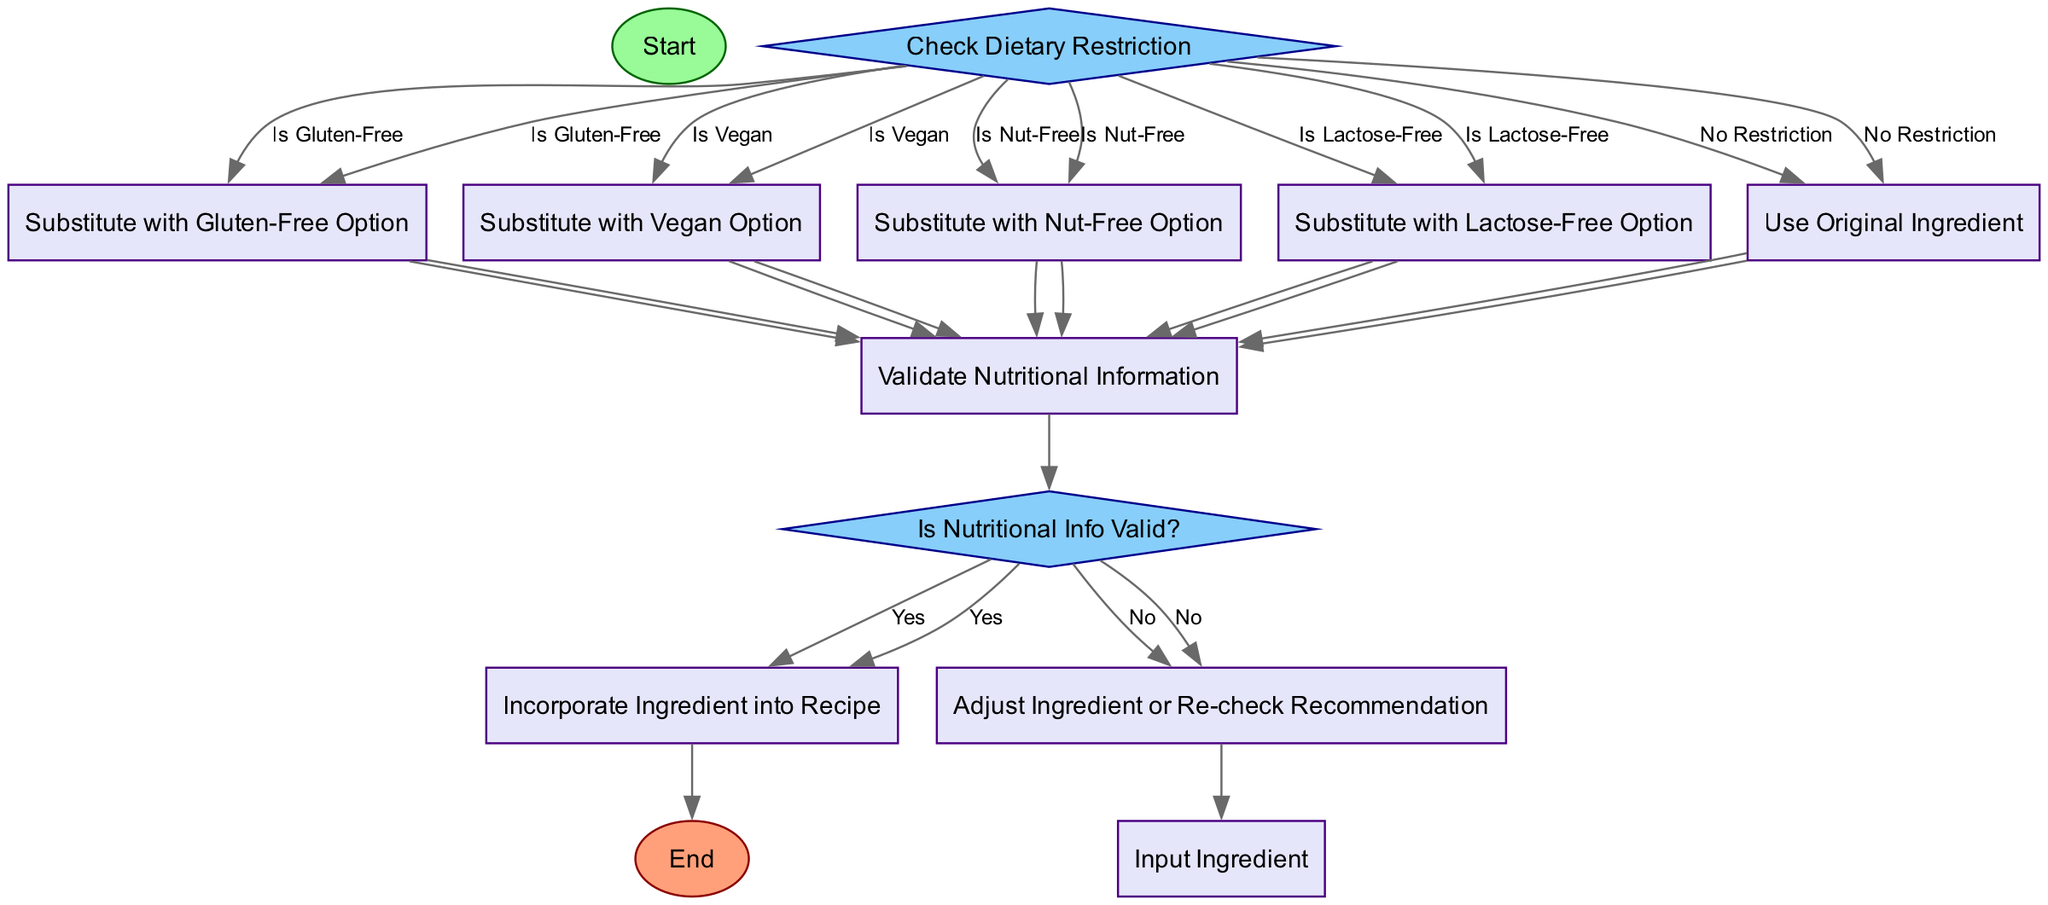What is the starting point of the flowchart? The diagram begins with a start node labeled "Start," which indicates where the workflow initiates.
Answer: Start How many decision nodes are present in the flowchart? There are two decision nodes in the flowchart: one checks for dietary restriction and the other validates nutritional information.
Answer: 2 What process follows the decision on dietary restrictions? After determining the dietary restriction, the flowchart directs to different substitution processes based on the dietary needs identified.
Answer: Substitute with Gluten-Free Option, Substitute with Vegan Option, Substitute with Nut-Free Option, Substitute with Lactose-Free Option, Use Original Ingredient What action occurs if the nutritional information is not valid? If the nutritional information is not valid, the flowchart specifies to "Adjust Ingredient or Re-check Recommendation" and returns to the input ingredient step.
Answer: Adjust Ingredient or Re-check Recommendation Which process represents the end of the workflow? The final process in the flowchart, marked as "End," signifies the conclusion of the workflow after an ingredient has been incorporated into a recipe.
Answer: End What happens if there is no dietary restriction identified? If no dietary restriction is identified, the flowchart proceeds to "Use Original Ingredient," indicating that the original ingredient can be utilized without any changes.
Answer: Use Original Ingredient Which node indicates the validation of nutritional information? The node that indicates the validation of nutritional information is labeled "Is Nutritional Info Valid?" which leads to further actions based on the outcome.
Answer: Is Nutritional Info Valid? If an ingredient is determined to be gluten-free, what is the next step? When an ingredient is identified as gluten-free, the workflow moves to the process labeled "Substitute with Gluten-Free Option," where a suitable alternative is chosen.
Answer: Substitute with Gluten-Free Option What is the next step after incorporating an ingredient into a recipe? After the inclusion of an ingredient into a recipe, the flowchart indicates that the workflow reaches its endpoint labeled "End."
Answer: End 